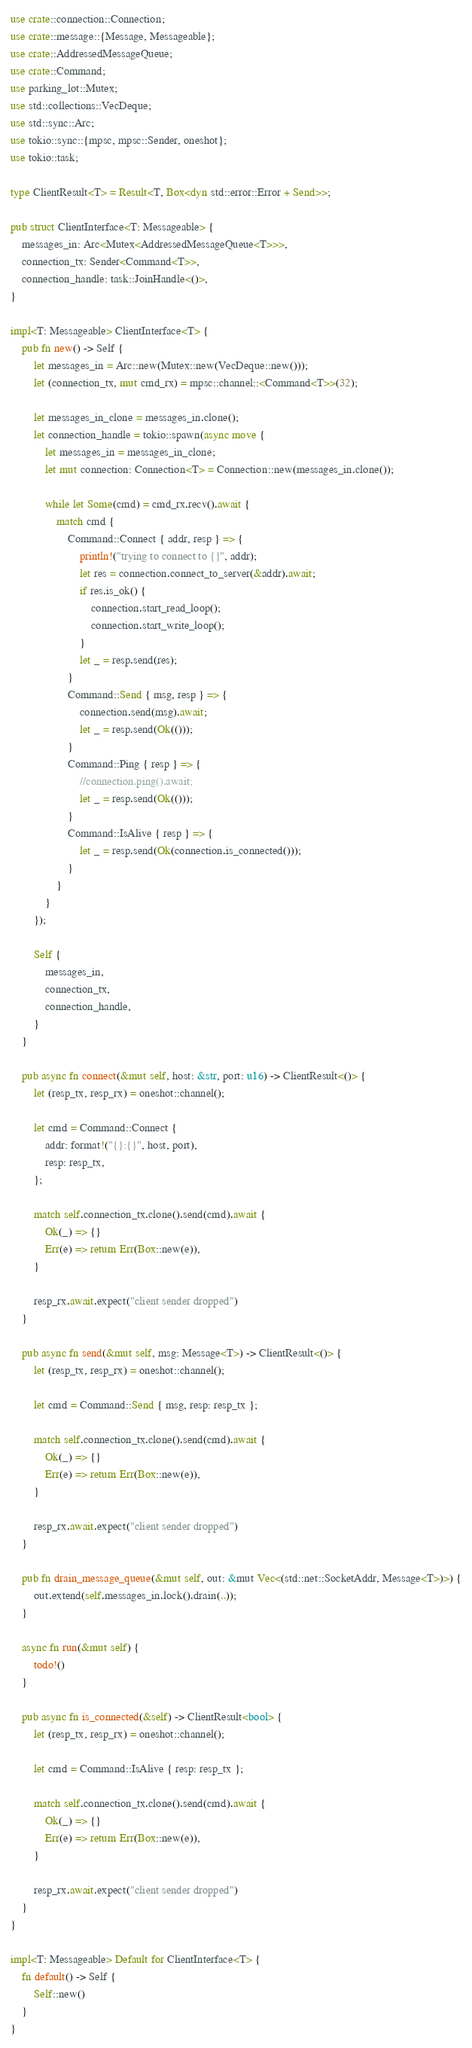<code> <loc_0><loc_0><loc_500><loc_500><_Rust_>use crate::connection::Connection;
use crate::message::{Message, Messageable};
use crate::AddressedMessageQueue;
use crate::Command;
use parking_lot::Mutex;
use std::collections::VecDeque;
use std::sync::Arc;
use tokio::sync::{mpsc, mpsc::Sender, oneshot};
use tokio::task;

type ClientResult<T> = Result<T, Box<dyn std::error::Error + Send>>;

pub struct ClientInterface<T: Messageable> {
    messages_in: Arc<Mutex<AddressedMessageQueue<T>>>,
    connection_tx: Sender<Command<T>>,
    connection_handle: task::JoinHandle<()>,
}

impl<T: Messageable> ClientInterface<T> {
    pub fn new() -> Self {
        let messages_in = Arc::new(Mutex::new(VecDeque::new()));
        let (connection_tx, mut cmd_rx) = mpsc::channel::<Command<T>>(32);

        let messages_in_clone = messages_in.clone();
        let connection_handle = tokio::spawn(async move {
            let messages_in = messages_in_clone;
            let mut connection: Connection<T> = Connection::new(messages_in.clone());

            while let Some(cmd) = cmd_rx.recv().await {
                match cmd {
                    Command::Connect { addr, resp } => {
                        println!("trying to connect to {}", addr);
                        let res = connection.connect_to_server(&addr).await;
                        if res.is_ok() {
                            connection.start_read_loop();
                            connection.start_write_loop();
                        }
                        let _ = resp.send(res);
                    }
                    Command::Send { msg, resp } => {
                        connection.send(msg).await;
                        let _ = resp.send(Ok(()));
                    }
                    Command::Ping { resp } => {
                        //connection.ping().await;
                        let _ = resp.send(Ok(()));
                    }
                    Command::IsAlive { resp } => {
                        let _ = resp.send(Ok(connection.is_connected()));
                    }
                }
            }
        });

        Self {
            messages_in,
            connection_tx,
            connection_handle,
        }
    }

    pub async fn connect(&mut self, host: &str, port: u16) -> ClientResult<()> {
        let (resp_tx, resp_rx) = oneshot::channel();

        let cmd = Command::Connect {
            addr: format!("{}:{}", host, port),
            resp: resp_tx,
        };

        match self.connection_tx.clone().send(cmd).await {
            Ok(_) => {}
            Err(e) => return Err(Box::new(e)),
        }

        resp_rx.await.expect("client sender dropped")
    }

    pub async fn send(&mut self, msg: Message<T>) -> ClientResult<()> {
        let (resp_tx, resp_rx) = oneshot::channel();

        let cmd = Command::Send { msg, resp: resp_tx };

        match self.connection_tx.clone().send(cmd).await {
            Ok(_) => {}
            Err(e) => return Err(Box::new(e)),
        }

        resp_rx.await.expect("client sender dropped")
    }

    pub fn drain_message_queue(&mut self, out: &mut Vec<(std::net::SocketAddr, Message<T>)>) {
        out.extend(self.messages_in.lock().drain(..));
    }

    async fn run(&mut self) {
        todo!()
    }

    pub async fn is_connected(&self) -> ClientResult<bool> {
        let (resp_tx, resp_rx) = oneshot::channel();

        let cmd = Command::IsAlive { resp: resp_tx };

        match self.connection_tx.clone().send(cmd).await {
            Ok(_) => {}
            Err(e) => return Err(Box::new(e)),
        }

        resp_rx.await.expect("client sender dropped")
    }
}

impl<T: Messageable> Default for ClientInterface<T> {
    fn default() -> Self {
        Self::new()
    }
}
</code> 